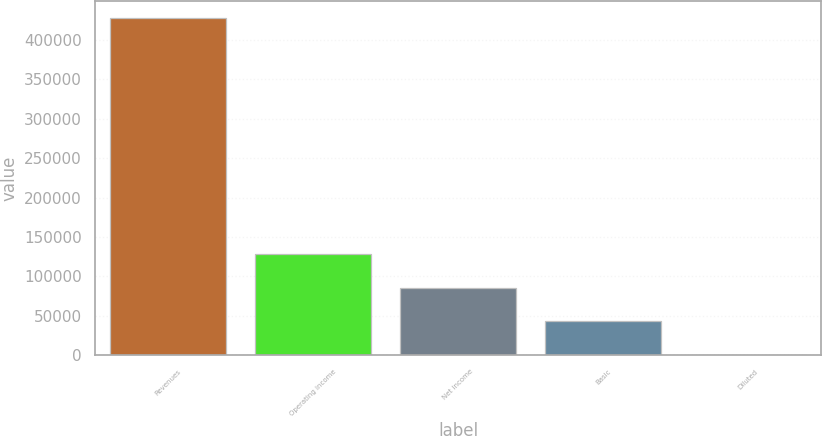<chart> <loc_0><loc_0><loc_500><loc_500><bar_chart><fcel>Revenues<fcel>Operating income<fcel>Net income<fcel>Basic<fcel>Diluted<nl><fcel>427694<fcel>128309<fcel>85539.2<fcel>42769.8<fcel>0.46<nl></chart> 